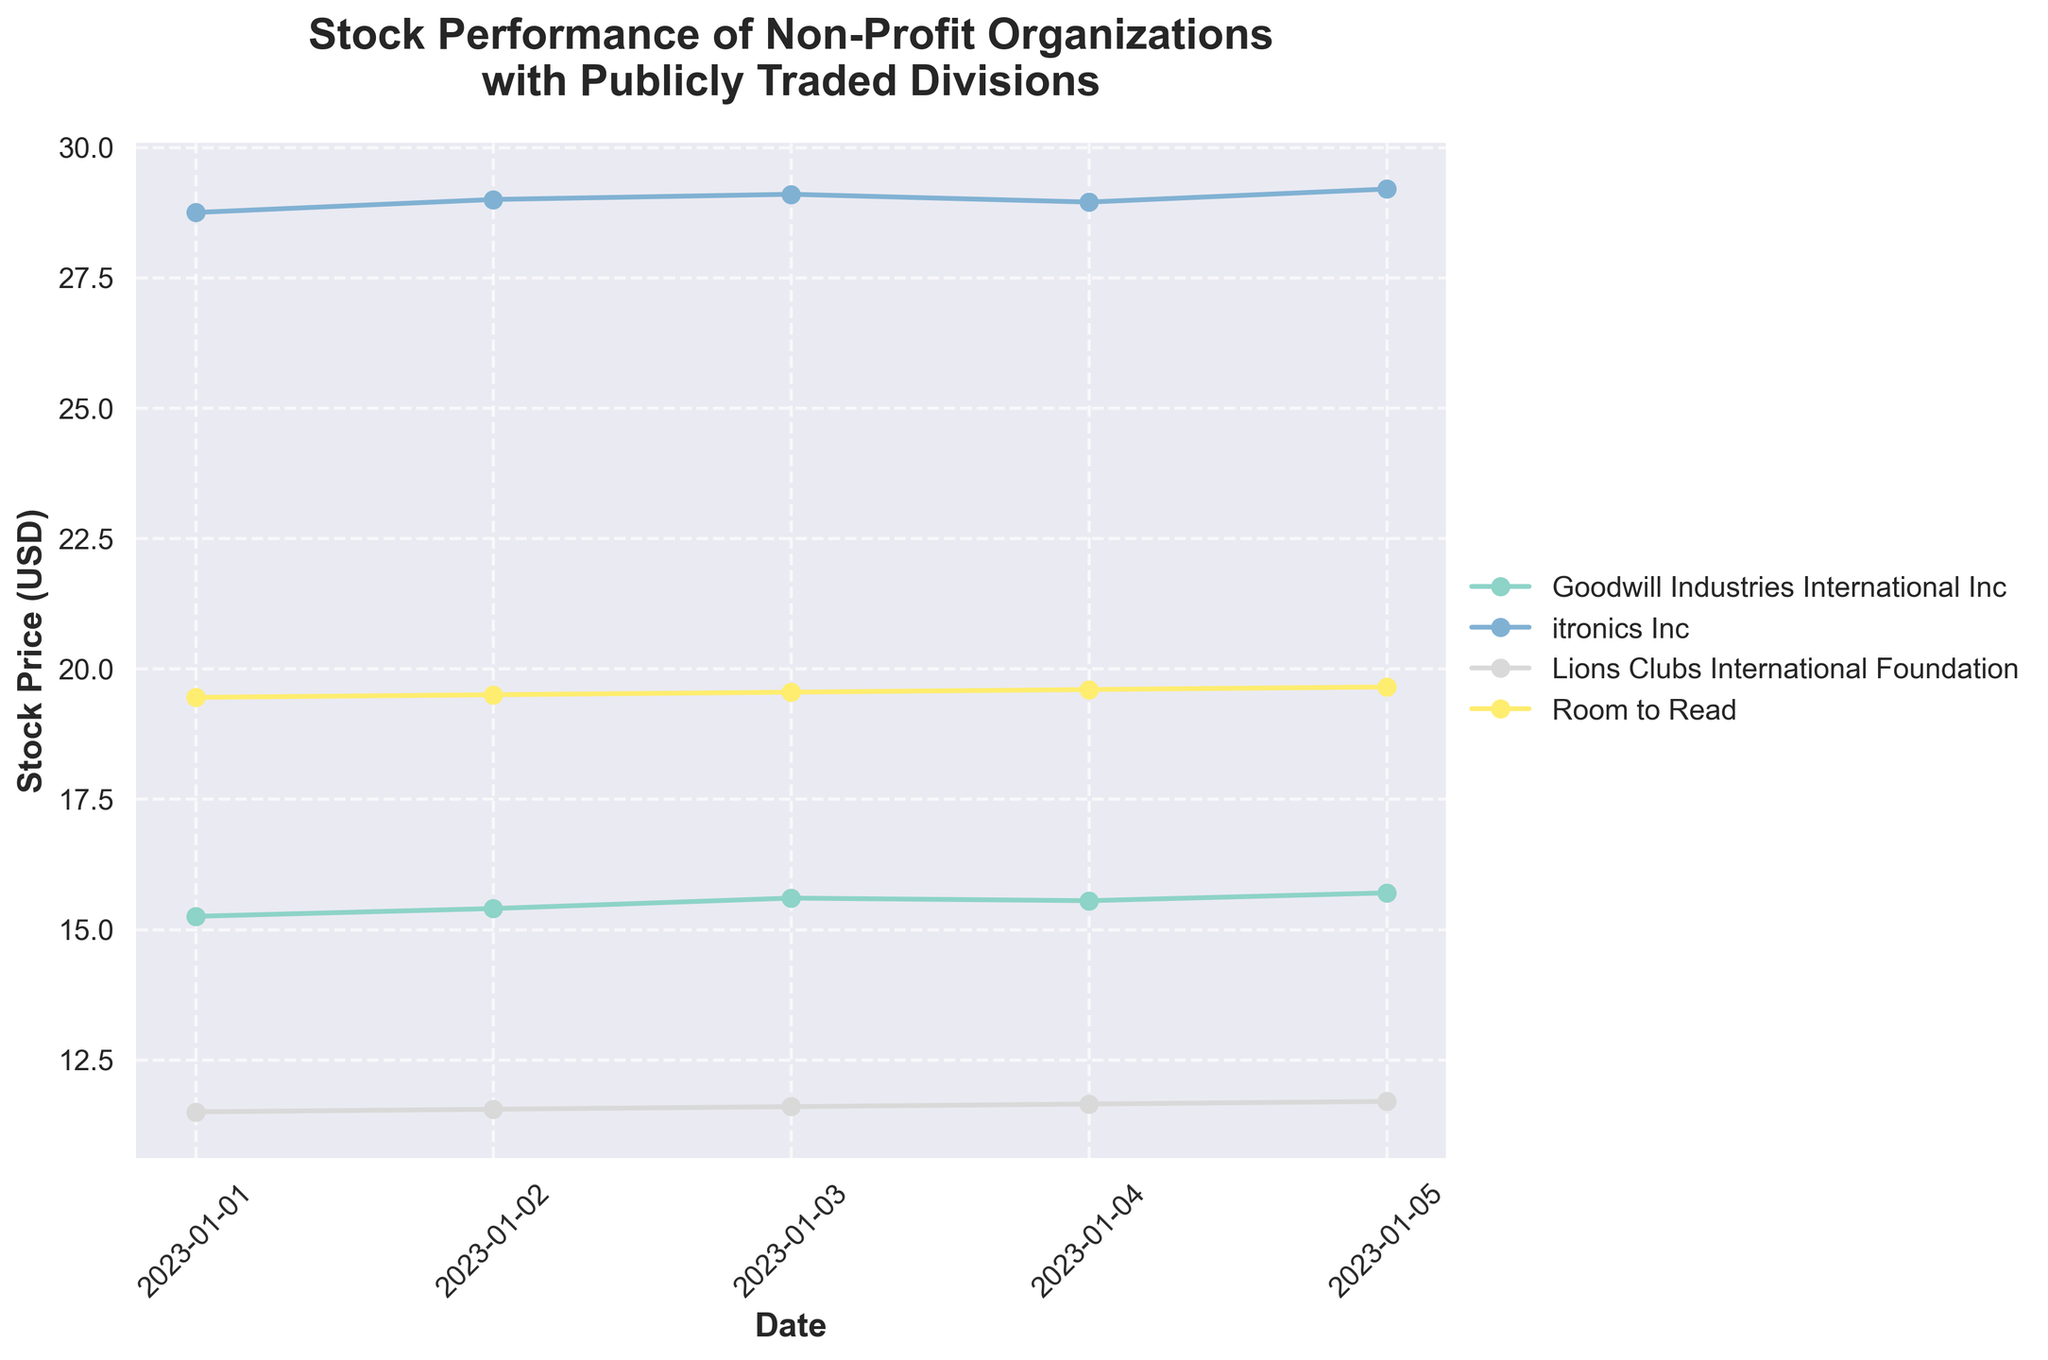What is the title of the plot? The title is displayed prominently at the top of the plot.
Answer: Stock Performance of Non-Profit Organizations with Publicly Traded Divisions What are the axes labels in the plot? The x-axis label is located at the bottom, and the y-axis label is on the left side of the plot.
Answer: Date (x-axis) and Stock Price (USD) (y-axis) How many companies are displayed in the plot? Each line on the plot represents a different company, and the legend shows the company names.
Answer: Four companies Which company had the highest stock price on 2023-01-01? Look at the data points for 2023-01-01 on the x-axis and compare their positions on the y-axis.
Answer: itronics Inc What is the trend of Room to Read's stock price over the given dates? Follow the line representing Room to Read from left to right to see if it goes up, down, or stays the same.
Answer: It is increasing What is the average stock price of Goodwill Industries International Inc from 2023-01-01 to 2023-01-05? Add the stock prices on each given date and divide by the number of days. (15.25 + 15.40 + 15.60 + 15.55 + 15.70) / 5
Answer: 15.50 USD On which date did itronics Inc see the lowest stock price? Identify the lowest point on the line representing itronics Inc and match it to the date on the x-axis.
Answer: 2023-01-04 Which company had the most stable stock price over the given dates? Compare the variations or fluctuations in the lines of all companies; the least fluctuating line represents the most stable stock price.
Answer: Lions Clubs International Foundation How does the stock price of Goodwill Industries International Inc on 2023-01-05 compare with Room to Read on the same date? Find both companies' stock prices for 2023-01-05 and compare the values.
Answer: 15.70 USD for Goodwill Industries and 19.65 USD for Room to Read What can be inferred about the overall stock performance of Lions Clubs International Foundation over the given dates? Check the direction and stability of the line representing Lions Clubs International Foundation over the dates.
Answer: It shows a steady increase 